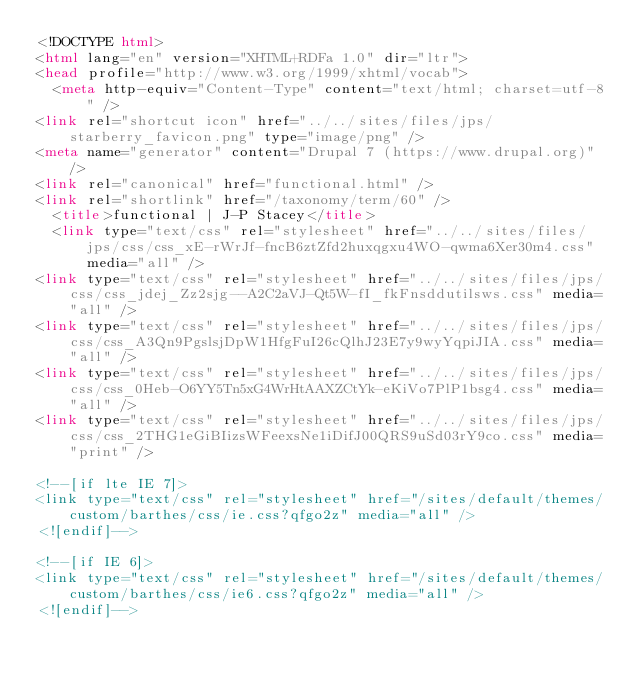<code> <loc_0><loc_0><loc_500><loc_500><_HTML_><!DOCTYPE html>
<html lang="en" version="XHTML+RDFa 1.0" dir="ltr">
<head profile="http://www.w3.org/1999/xhtml/vocab">
  <meta http-equiv="Content-Type" content="text/html; charset=utf-8" />
<link rel="shortcut icon" href="../../sites/files/jps/starberry_favicon.png" type="image/png" />
<meta name="generator" content="Drupal 7 (https://www.drupal.org)" />
<link rel="canonical" href="functional.html" />
<link rel="shortlink" href="/taxonomy/term/60" />
  <title>functional | J-P Stacey</title>
  <link type="text/css" rel="stylesheet" href="../../sites/files/jps/css/css_xE-rWrJf-fncB6ztZfd2huxqgxu4WO-qwma6Xer30m4.css" media="all" />
<link type="text/css" rel="stylesheet" href="../../sites/files/jps/css/css_jdej_Zz2sjg--A2C2aVJ-Qt5W-fI_fkFnsddutilsws.css" media="all" />
<link type="text/css" rel="stylesheet" href="../../sites/files/jps/css/css_A3Qn9PgslsjDpW1HfgFuI26cQlhJ23E7y9wyYqpiJIA.css" media="all" />
<link type="text/css" rel="stylesheet" href="../../sites/files/jps/css/css_0Heb-O6YY5Tn5xG4WrHtAAXZCtYk-eKiVo7PlP1bsg4.css" media="all" />
<link type="text/css" rel="stylesheet" href="../../sites/files/jps/css/css_2THG1eGiBIizsWFeexsNe1iDifJ00QRS9uSd03rY9co.css" media="print" />

<!--[if lte IE 7]>
<link type="text/css" rel="stylesheet" href="/sites/default/themes/custom/barthes/css/ie.css?qfgo2z" media="all" />
<![endif]-->

<!--[if IE 6]>
<link type="text/css" rel="stylesheet" href="/sites/default/themes/custom/barthes/css/ie6.css?qfgo2z" media="all" />
<![endif]--></code> 